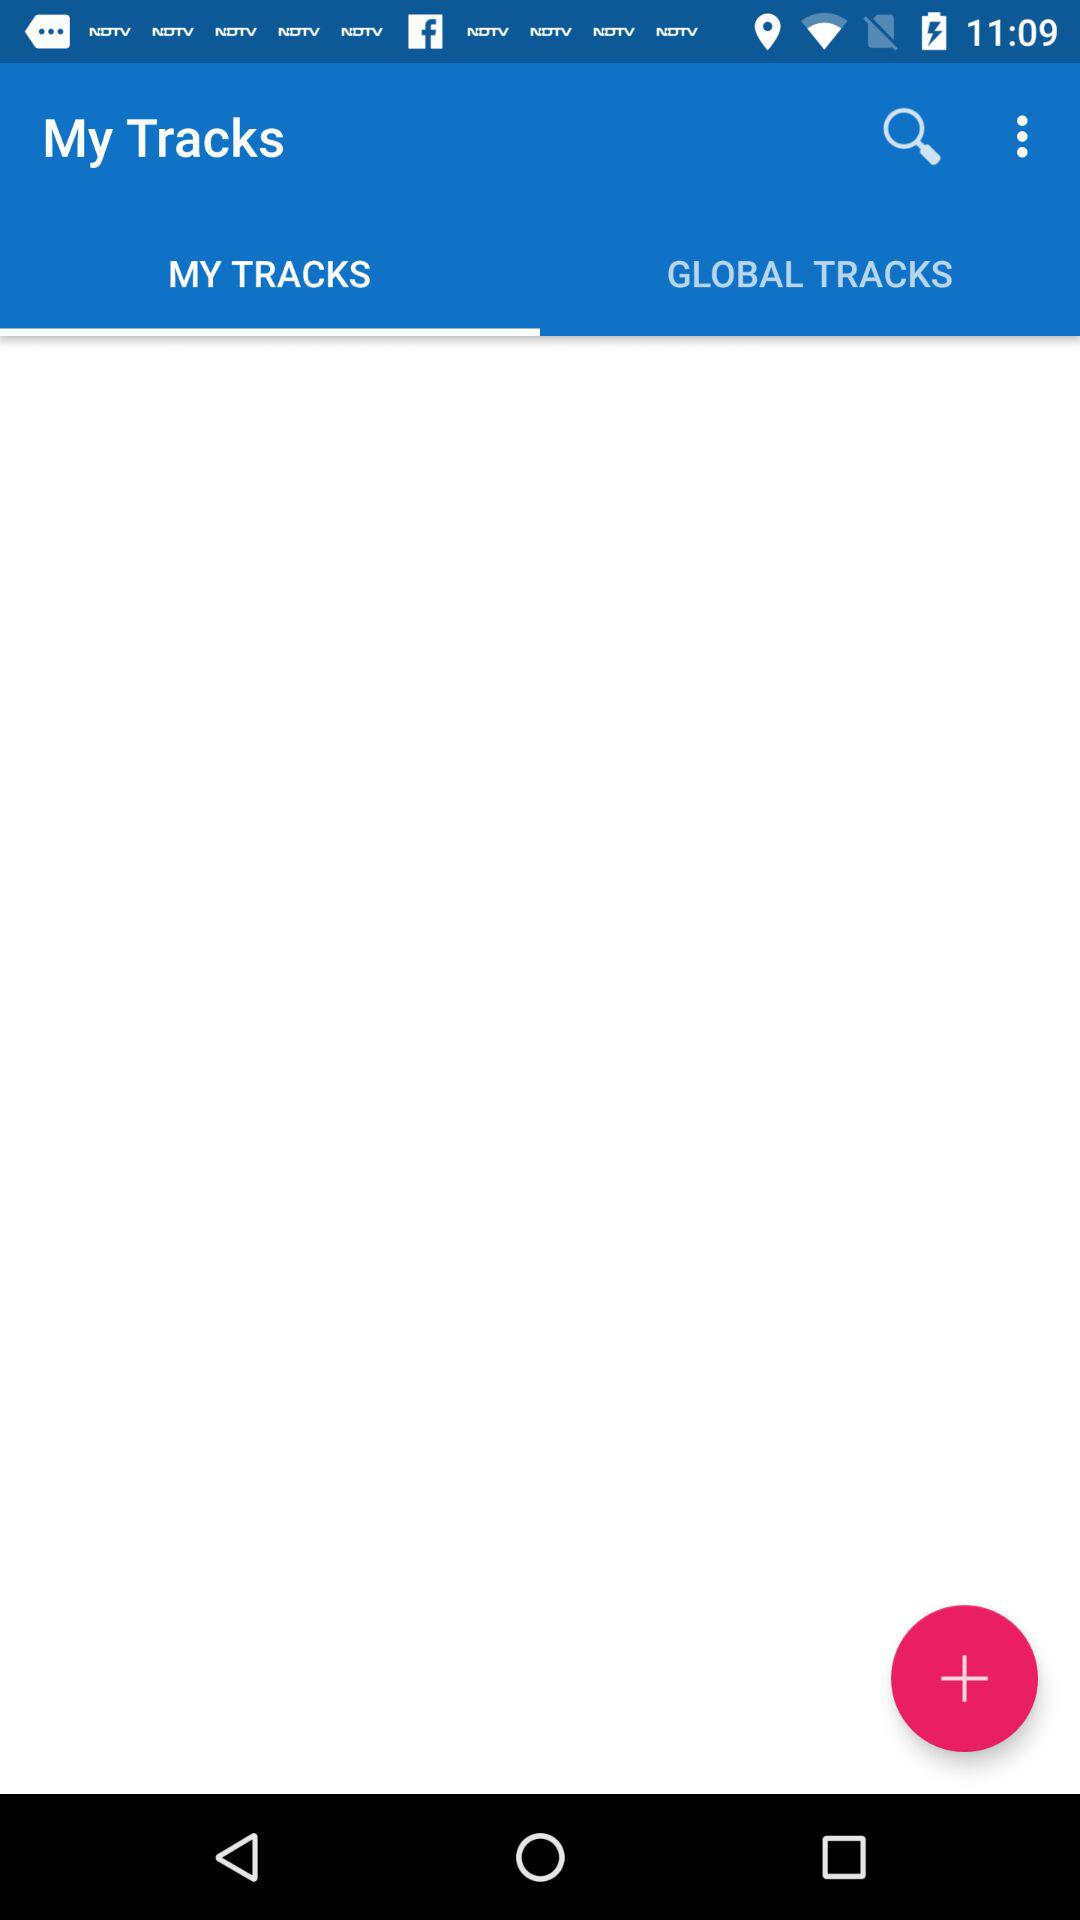Which tab has been selected? The selected tab is "MY TRACKS". 